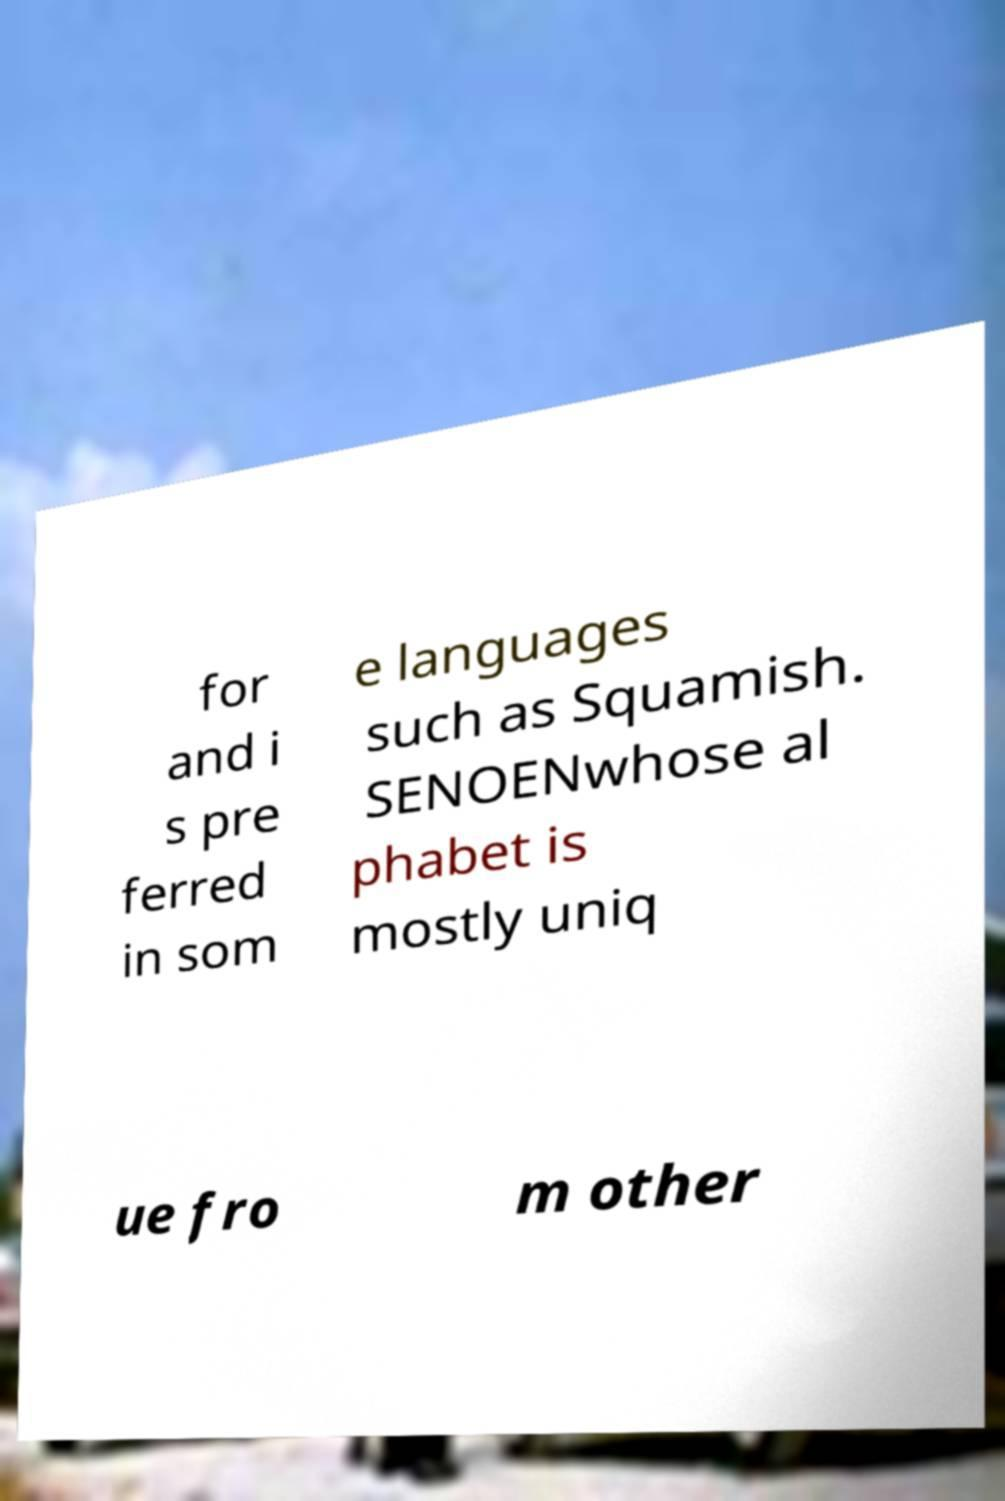Please read and relay the text visible in this image. What does it say? for and i s pre ferred in som e languages such as Squamish. SENOENwhose al phabet is mostly uniq ue fro m other 